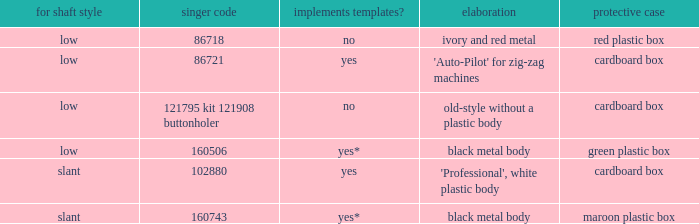Would you mind parsing the complete table? {'header': ['for shaft style', 'singer code', 'implements templates?', 'elaboration', 'protective case'], 'rows': [['low', '86718', 'no', 'ivory and red metal', 'red plastic box'], ['low', '86721', 'yes', "'Auto-Pilot' for zig-zag machines", 'cardboard box'], ['low', '121795 kit 121908 buttonholer', 'no', 'old-style without a plastic body', 'cardboard box'], ['low', '160506', 'yes*', 'black metal body', 'green plastic box'], ['slant', '102880', 'yes', "'Professional', white plastic body", 'cardboard box'], ['slant', '160743', 'yes*', 'black metal body', 'maroon plastic box']]} What's the description of the buttonholer whose singer part number is 121795 kit 121908 buttonholer? Old-style without a plastic body. 